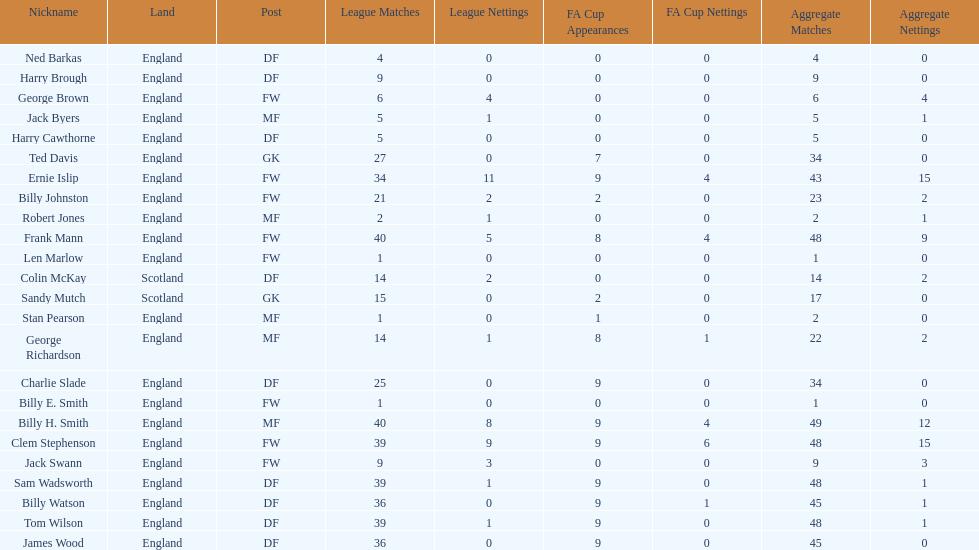The least number of total appearances 1. 